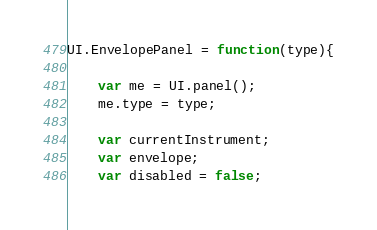<code> <loc_0><loc_0><loc_500><loc_500><_JavaScript_>UI.EnvelopePanel = function(type){

	var me = UI.panel();
	me.type = type;

	var currentInstrument;
	var envelope;
	var disabled = false;
</code> 